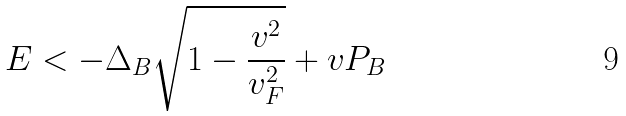Convert formula to latex. <formula><loc_0><loc_0><loc_500><loc_500>E < - \Delta _ { B } \sqrt { 1 - \frac { v ^ { 2 } } { v _ { F } ^ { 2 } } } + v P _ { B }</formula> 